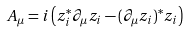<formula> <loc_0><loc_0><loc_500><loc_500>A _ { \mu } = i \left ( z _ { i } ^ { * } \partial _ { \mu } z _ { i } - ( \partial _ { \mu } z _ { i } ) ^ { * } z _ { i } \right )</formula> 